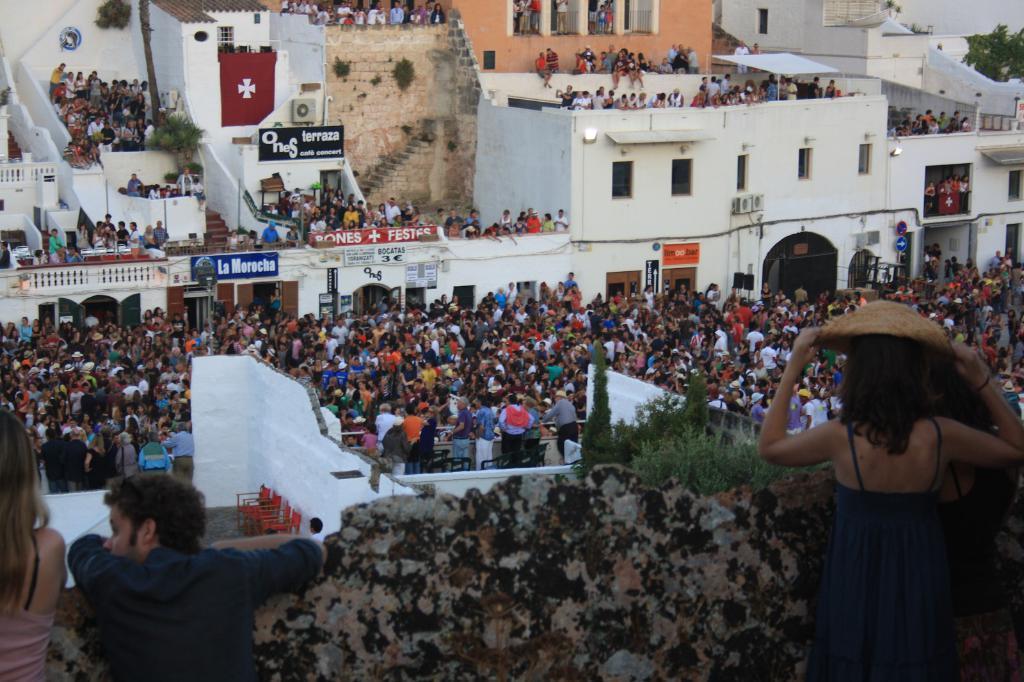In one or two sentences, can you explain what this image depicts? In the foreground of the image we can see group of persons. One woman is wearing a blue dress and a hat. In the center of the image we can see group of people standing, chairs and walls. In the background, we can see a group of buildings with some text on them ,a staircase, air conditioner and a group of trees. 